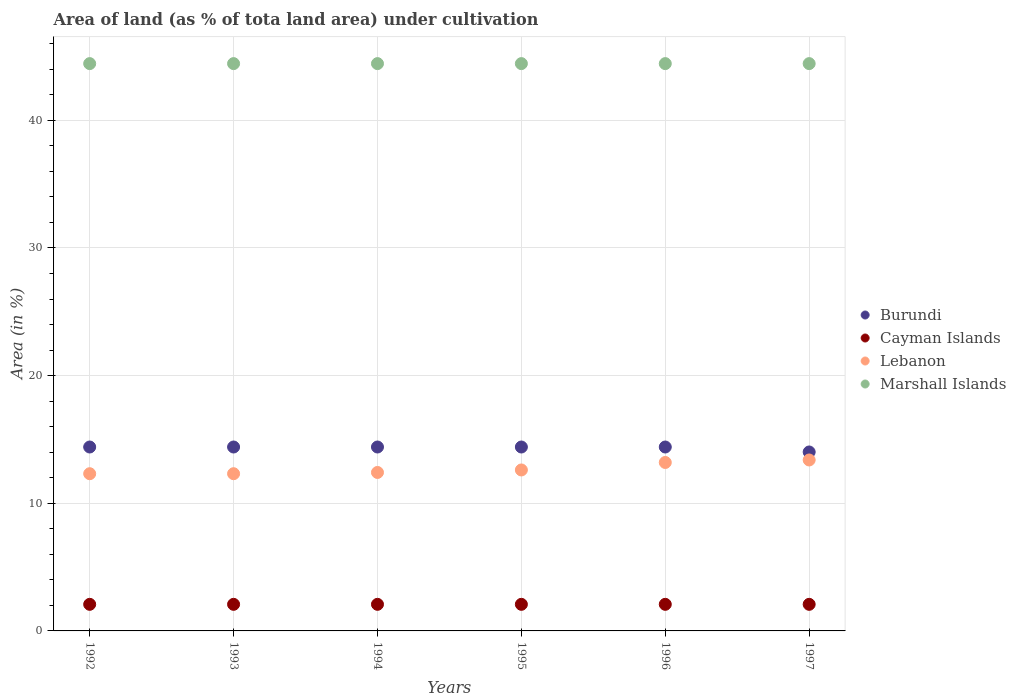Is the number of dotlines equal to the number of legend labels?
Offer a very short reply. Yes. What is the percentage of land under cultivation in Burundi in 1993?
Your answer should be compact. 14.41. Across all years, what is the maximum percentage of land under cultivation in Marshall Islands?
Provide a short and direct response. 44.44. Across all years, what is the minimum percentage of land under cultivation in Lebanon?
Provide a short and direct response. 12.32. In which year was the percentage of land under cultivation in Cayman Islands maximum?
Keep it short and to the point. 1992. In which year was the percentage of land under cultivation in Lebanon minimum?
Keep it short and to the point. 1992. What is the total percentage of land under cultivation in Burundi in the graph?
Provide a succinct answer. 86.06. What is the difference between the percentage of land under cultivation in Lebanon in 1992 and that in 1994?
Your answer should be compact. -0.1. What is the difference between the percentage of land under cultivation in Lebanon in 1993 and the percentage of land under cultivation in Cayman Islands in 1995?
Give a very brief answer. 10.23. What is the average percentage of land under cultivation in Lebanon per year?
Offer a very short reply. 12.71. In the year 1992, what is the difference between the percentage of land under cultivation in Burundi and percentage of land under cultivation in Lebanon?
Provide a short and direct response. 2.09. In how many years, is the percentage of land under cultivation in Lebanon greater than 16 %?
Offer a terse response. 0. What is the ratio of the percentage of land under cultivation in Lebanon in 1995 to that in 1996?
Provide a succinct answer. 0.96. Is the difference between the percentage of land under cultivation in Burundi in 1992 and 1993 greater than the difference between the percentage of land under cultivation in Lebanon in 1992 and 1993?
Your response must be concise. No. What is the difference between the highest and the lowest percentage of land under cultivation in Burundi?
Keep it short and to the point. 0.39. In how many years, is the percentage of land under cultivation in Burundi greater than the average percentage of land under cultivation in Burundi taken over all years?
Your response must be concise. 5. Is the sum of the percentage of land under cultivation in Lebanon in 1992 and 1993 greater than the maximum percentage of land under cultivation in Burundi across all years?
Make the answer very short. Yes. Is it the case that in every year, the sum of the percentage of land under cultivation in Burundi and percentage of land under cultivation in Lebanon  is greater than the sum of percentage of land under cultivation in Marshall Islands and percentage of land under cultivation in Cayman Islands?
Make the answer very short. Yes. Is it the case that in every year, the sum of the percentage of land under cultivation in Cayman Islands and percentage of land under cultivation in Marshall Islands  is greater than the percentage of land under cultivation in Burundi?
Your response must be concise. Yes. Is the percentage of land under cultivation in Lebanon strictly greater than the percentage of land under cultivation in Cayman Islands over the years?
Provide a succinct answer. Yes. Is the percentage of land under cultivation in Burundi strictly less than the percentage of land under cultivation in Marshall Islands over the years?
Your answer should be very brief. Yes. How many years are there in the graph?
Offer a very short reply. 6. What is the difference between two consecutive major ticks on the Y-axis?
Make the answer very short. 10. How many legend labels are there?
Offer a very short reply. 4. How are the legend labels stacked?
Offer a terse response. Vertical. What is the title of the graph?
Make the answer very short. Area of land (as % of tota land area) under cultivation. What is the label or title of the X-axis?
Make the answer very short. Years. What is the label or title of the Y-axis?
Make the answer very short. Area (in %). What is the Area (in %) of Burundi in 1992?
Ensure brevity in your answer.  14.41. What is the Area (in %) of Cayman Islands in 1992?
Your answer should be compact. 2.08. What is the Area (in %) of Lebanon in 1992?
Offer a terse response. 12.32. What is the Area (in %) in Marshall Islands in 1992?
Provide a succinct answer. 44.44. What is the Area (in %) in Burundi in 1993?
Your answer should be very brief. 14.41. What is the Area (in %) of Cayman Islands in 1993?
Your answer should be compact. 2.08. What is the Area (in %) of Lebanon in 1993?
Offer a very short reply. 12.32. What is the Area (in %) in Marshall Islands in 1993?
Keep it short and to the point. 44.44. What is the Area (in %) in Burundi in 1994?
Your response must be concise. 14.41. What is the Area (in %) of Cayman Islands in 1994?
Make the answer very short. 2.08. What is the Area (in %) in Lebanon in 1994?
Provide a succinct answer. 12.41. What is the Area (in %) of Marshall Islands in 1994?
Keep it short and to the point. 44.44. What is the Area (in %) of Burundi in 1995?
Ensure brevity in your answer.  14.41. What is the Area (in %) in Cayman Islands in 1995?
Ensure brevity in your answer.  2.08. What is the Area (in %) of Lebanon in 1995?
Ensure brevity in your answer.  12.61. What is the Area (in %) of Marshall Islands in 1995?
Provide a short and direct response. 44.44. What is the Area (in %) in Burundi in 1996?
Your answer should be compact. 14.41. What is the Area (in %) of Cayman Islands in 1996?
Your answer should be very brief. 2.08. What is the Area (in %) in Lebanon in 1996?
Provide a short and direct response. 13.2. What is the Area (in %) in Marshall Islands in 1996?
Give a very brief answer. 44.44. What is the Area (in %) of Burundi in 1997?
Offer a terse response. 14.02. What is the Area (in %) in Cayman Islands in 1997?
Provide a short and direct response. 2.08. What is the Area (in %) of Lebanon in 1997?
Offer a very short reply. 13.39. What is the Area (in %) of Marshall Islands in 1997?
Give a very brief answer. 44.44. Across all years, what is the maximum Area (in %) of Burundi?
Your response must be concise. 14.41. Across all years, what is the maximum Area (in %) of Cayman Islands?
Your answer should be compact. 2.08. Across all years, what is the maximum Area (in %) in Lebanon?
Offer a terse response. 13.39. Across all years, what is the maximum Area (in %) of Marshall Islands?
Provide a short and direct response. 44.44. Across all years, what is the minimum Area (in %) of Burundi?
Provide a short and direct response. 14.02. Across all years, what is the minimum Area (in %) in Cayman Islands?
Ensure brevity in your answer.  2.08. Across all years, what is the minimum Area (in %) in Lebanon?
Your response must be concise. 12.32. Across all years, what is the minimum Area (in %) of Marshall Islands?
Offer a terse response. 44.44. What is the total Area (in %) of Burundi in the graph?
Ensure brevity in your answer.  86.06. What is the total Area (in %) in Cayman Islands in the graph?
Offer a terse response. 12.5. What is the total Area (in %) in Lebanon in the graph?
Make the answer very short. 76.25. What is the total Area (in %) of Marshall Islands in the graph?
Provide a short and direct response. 266.67. What is the difference between the Area (in %) in Burundi in 1992 and that in 1993?
Offer a terse response. 0. What is the difference between the Area (in %) in Lebanon in 1992 and that in 1993?
Provide a succinct answer. 0. What is the difference between the Area (in %) of Burundi in 1992 and that in 1994?
Keep it short and to the point. 0. What is the difference between the Area (in %) of Lebanon in 1992 and that in 1994?
Provide a succinct answer. -0.1. What is the difference between the Area (in %) in Burundi in 1992 and that in 1995?
Keep it short and to the point. 0. What is the difference between the Area (in %) in Lebanon in 1992 and that in 1995?
Ensure brevity in your answer.  -0.29. What is the difference between the Area (in %) in Marshall Islands in 1992 and that in 1995?
Keep it short and to the point. 0. What is the difference between the Area (in %) in Lebanon in 1992 and that in 1996?
Ensure brevity in your answer.  -0.88. What is the difference between the Area (in %) of Marshall Islands in 1992 and that in 1996?
Give a very brief answer. 0. What is the difference between the Area (in %) of Burundi in 1992 and that in 1997?
Keep it short and to the point. 0.39. What is the difference between the Area (in %) in Lebanon in 1992 and that in 1997?
Your answer should be very brief. -1.08. What is the difference between the Area (in %) of Marshall Islands in 1992 and that in 1997?
Keep it short and to the point. 0. What is the difference between the Area (in %) in Cayman Islands in 1993 and that in 1994?
Provide a succinct answer. 0. What is the difference between the Area (in %) in Lebanon in 1993 and that in 1994?
Give a very brief answer. -0.1. What is the difference between the Area (in %) in Marshall Islands in 1993 and that in 1994?
Ensure brevity in your answer.  0. What is the difference between the Area (in %) in Burundi in 1993 and that in 1995?
Keep it short and to the point. 0. What is the difference between the Area (in %) in Lebanon in 1993 and that in 1995?
Your answer should be very brief. -0.29. What is the difference between the Area (in %) of Cayman Islands in 1993 and that in 1996?
Your response must be concise. 0. What is the difference between the Area (in %) in Lebanon in 1993 and that in 1996?
Keep it short and to the point. -0.88. What is the difference between the Area (in %) in Burundi in 1993 and that in 1997?
Offer a terse response. 0.39. What is the difference between the Area (in %) in Lebanon in 1993 and that in 1997?
Your response must be concise. -1.08. What is the difference between the Area (in %) in Marshall Islands in 1993 and that in 1997?
Ensure brevity in your answer.  0. What is the difference between the Area (in %) of Lebanon in 1994 and that in 1995?
Offer a terse response. -0.2. What is the difference between the Area (in %) in Marshall Islands in 1994 and that in 1995?
Offer a terse response. 0. What is the difference between the Area (in %) of Cayman Islands in 1994 and that in 1996?
Offer a very short reply. 0. What is the difference between the Area (in %) of Lebanon in 1994 and that in 1996?
Ensure brevity in your answer.  -0.78. What is the difference between the Area (in %) of Burundi in 1994 and that in 1997?
Your answer should be compact. 0.39. What is the difference between the Area (in %) of Lebanon in 1994 and that in 1997?
Provide a short and direct response. -0.98. What is the difference between the Area (in %) of Burundi in 1995 and that in 1996?
Offer a terse response. 0. What is the difference between the Area (in %) of Lebanon in 1995 and that in 1996?
Keep it short and to the point. -0.59. What is the difference between the Area (in %) in Marshall Islands in 1995 and that in 1996?
Make the answer very short. 0. What is the difference between the Area (in %) in Burundi in 1995 and that in 1997?
Provide a short and direct response. 0.39. What is the difference between the Area (in %) of Cayman Islands in 1995 and that in 1997?
Provide a succinct answer. 0. What is the difference between the Area (in %) in Lebanon in 1995 and that in 1997?
Your answer should be very brief. -0.78. What is the difference between the Area (in %) in Burundi in 1996 and that in 1997?
Your response must be concise. 0.39. What is the difference between the Area (in %) in Lebanon in 1996 and that in 1997?
Your answer should be very brief. -0.2. What is the difference between the Area (in %) of Burundi in 1992 and the Area (in %) of Cayman Islands in 1993?
Offer a very short reply. 12.32. What is the difference between the Area (in %) in Burundi in 1992 and the Area (in %) in Lebanon in 1993?
Keep it short and to the point. 2.09. What is the difference between the Area (in %) in Burundi in 1992 and the Area (in %) in Marshall Islands in 1993?
Your response must be concise. -30.04. What is the difference between the Area (in %) of Cayman Islands in 1992 and the Area (in %) of Lebanon in 1993?
Your answer should be compact. -10.23. What is the difference between the Area (in %) in Cayman Islands in 1992 and the Area (in %) in Marshall Islands in 1993?
Your answer should be very brief. -42.36. What is the difference between the Area (in %) in Lebanon in 1992 and the Area (in %) in Marshall Islands in 1993?
Ensure brevity in your answer.  -32.13. What is the difference between the Area (in %) of Burundi in 1992 and the Area (in %) of Cayman Islands in 1994?
Offer a terse response. 12.32. What is the difference between the Area (in %) in Burundi in 1992 and the Area (in %) in Lebanon in 1994?
Your response must be concise. 1.99. What is the difference between the Area (in %) of Burundi in 1992 and the Area (in %) of Marshall Islands in 1994?
Provide a succinct answer. -30.04. What is the difference between the Area (in %) in Cayman Islands in 1992 and the Area (in %) in Lebanon in 1994?
Ensure brevity in your answer.  -10.33. What is the difference between the Area (in %) in Cayman Islands in 1992 and the Area (in %) in Marshall Islands in 1994?
Ensure brevity in your answer.  -42.36. What is the difference between the Area (in %) of Lebanon in 1992 and the Area (in %) of Marshall Islands in 1994?
Provide a succinct answer. -32.13. What is the difference between the Area (in %) in Burundi in 1992 and the Area (in %) in Cayman Islands in 1995?
Offer a very short reply. 12.32. What is the difference between the Area (in %) in Burundi in 1992 and the Area (in %) in Lebanon in 1995?
Your answer should be compact. 1.8. What is the difference between the Area (in %) of Burundi in 1992 and the Area (in %) of Marshall Islands in 1995?
Your response must be concise. -30.04. What is the difference between the Area (in %) in Cayman Islands in 1992 and the Area (in %) in Lebanon in 1995?
Offer a terse response. -10.53. What is the difference between the Area (in %) of Cayman Islands in 1992 and the Area (in %) of Marshall Islands in 1995?
Offer a very short reply. -42.36. What is the difference between the Area (in %) in Lebanon in 1992 and the Area (in %) in Marshall Islands in 1995?
Keep it short and to the point. -32.13. What is the difference between the Area (in %) in Burundi in 1992 and the Area (in %) in Cayman Islands in 1996?
Your response must be concise. 12.32. What is the difference between the Area (in %) of Burundi in 1992 and the Area (in %) of Lebanon in 1996?
Provide a succinct answer. 1.21. What is the difference between the Area (in %) of Burundi in 1992 and the Area (in %) of Marshall Islands in 1996?
Ensure brevity in your answer.  -30.04. What is the difference between the Area (in %) of Cayman Islands in 1992 and the Area (in %) of Lebanon in 1996?
Offer a very short reply. -11.11. What is the difference between the Area (in %) of Cayman Islands in 1992 and the Area (in %) of Marshall Islands in 1996?
Ensure brevity in your answer.  -42.36. What is the difference between the Area (in %) in Lebanon in 1992 and the Area (in %) in Marshall Islands in 1996?
Provide a succinct answer. -32.13. What is the difference between the Area (in %) of Burundi in 1992 and the Area (in %) of Cayman Islands in 1997?
Keep it short and to the point. 12.32. What is the difference between the Area (in %) of Burundi in 1992 and the Area (in %) of Lebanon in 1997?
Keep it short and to the point. 1.02. What is the difference between the Area (in %) of Burundi in 1992 and the Area (in %) of Marshall Islands in 1997?
Offer a terse response. -30.04. What is the difference between the Area (in %) in Cayman Islands in 1992 and the Area (in %) in Lebanon in 1997?
Ensure brevity in your answer.  -11.31. What is the difference between the Area (in %) of Cayman Islands in 1992 and the Area (in %) of Marshall Islands in 1997?
Offer a terse response. -42.36. What is the difference between the Area (in %) in Lebanon in 1992 and the Area (in %) in Marshall Islands in 1997?
Provide a succinct answer. -32.13. What is the difference between the Area (in %) of Burundi in 1993 and the Area (in %) of Cayman Islands in 1994?
Provide a succinct answer. 12.32. What is the difference between the Area (in %) of Burundi in 1993 and the Area (in %) of Lebanon in 1994?
Offer a terse response. 1.99. What is the difference between the Area (in %) of Burundi in 1993 and the Area (in %) of Marshall Islands in 1994?
Offer a very short reply. -30.04. What is the difference between the Area (in %) in Cayman Islands in 1993 and the Area (in %) in Lebanon in 1994?
Your response must be concise. -10.33. What is the difference between the Area (in %) in Cayman Islands in 1993 and the Area (in %) in Marshall Islands in 1994?
Offer a terse response. -42.36. What is the difference between the Area (in %) in Lebanon in 1993 and the Area (in %) in Marshall Islands in 1994?
Your answer should be compact. -32.13. What is the difference between the Area (in %) in Burundi in 1993 and the Area (in %) in Cayman Islands in 1995?
Your answer should be very brief. 12.32. What is the difference between the Area (in %) of Burundi in 1993 and the Area (in %) of Lebanon in 1995?
Offer a very short reply. 1.8. What is the difference between the Area (in %) of Burundi in 1993 and the Area (in %) of Marshall Islands in 1995?
Ensure brevity in your answer.  -30.04. What is the difference between the Area (in %) in Cayman Islands in 1993 and the Area (in %) in Lebanon in 1995?
Make the answer very short. -10.53. What is the difference between the Area (in %) in Cayman Islands in 1993 and the Area (in %) in Marshall Islands in 1995?
Provide a short and direct response. -42.36. What is the difference between the Area (in %) of Lebanon in 1993 and the Area (in %) of Marshall Islands in 1995?
Offer a very short reply. -32.13. What is the difference between the Area (in %) in Burundi in 1993 and the Area (in %) in Cayman Islands in 1996?
Provide a succinct answer. 12.32. What is the difference between the Area (in %) in Burundi in 1993 and the Area (in %) in Lebanon in 1996?
Ensure brevity in your answer.  1.21. What is the difference between the Area (in %) of Burundi in 1993 and the Area (in %) of Marshall Islands in 1996?
Provide a succinct answer. -30.04. What is the difference between the Area (in %) in Cayman Islands in 1993 and the Area (in %) in Lebanon in 1996?
Your response must be concise. -11.11. What is the difference between the Area (in %) of Cayman Islands in 1993 and the Area (in %) of Marshall Islands in 1996?
Provide a succinct answer. -42.36. What is the difference between the Area (in %) in Lebanon in 1993 and the Area (in %) in Marshall Islands in 1996?
Provide a short and direct response. -32.13. What is the difference between the Area (in %) of Burundi in 1993 and the Area (in %) of Cayman Islands in 1997?
Your answer should be compact. 12.32. What is the difference between the Area (in %) of Burundi in 1993 and the Area (in %) of Lebanon in 1997?
Your answer should be compact. 1.02. What is the difference between the Area (in %) of Burundi in 1993 and the Area (in %) of Marshall Islands in 1997?
Make the answer very short. -30.04. What is the difference between the Area (in %) in Cayman Islands in 1993 and the Area (in %) in Lebanon in 1997?
Your response must be concise. -11.31. What is the difference between the Area (in %) in Cayman Islands in 1993 and the Area (in %) in Marshall Islands in 1997?
Offer a very short reply. -42.36. What is the difference between the Area (in %) of Lebanon in 1993 and the Area (in %) of Marshall Islands in 1997?
Give a very brief answer. -32.13. What is the difference between the Area (in %) in Burundi in 1994 and the Area (in %) in Cayman Islands in 1995?
Ensure brevity in your answer.  12.32. What is the difference between the Area (in %) of Burundi in 1994 and the Area (in %) of Lebanon in 1995?
Provide a succinct answer. 1.8. What is the difference between the Area (in %) of Burundi in 1994 and the Area (in %) of Marshall Islands in 1995?
Your response must be concise. -30.04. What is the difference between the Area (in %) of Cayman Islands in 1994 and the Area (in %) of Lebanon in 1995?
Ensure brevity in your answer.  -10.53. What is the difference between the Area (in %) in Cayman Islands in 1994 and the Area (in %) in Marshall Islands in 1995?
Offer a very short reply. -42.36. What is the difference between the Area (in %) in Lebanon in 1994 and the Area (in %) in Marshall Islands in 1995?
Your answer should be very brief. -32.03. What is the difference between the Area (in %) of Burundi in 1994 and the Area (in %) of Cayman Islands in 1996?
Provide a succinct answer. 12.32. What is the difference between the Area (in %) in Burundi in 1994 and the Area (in %) in Lebanon in 1996?
Your response must be concise. 1.21. What is the difference between the Area (in %) in Burundi in 1994 and the Area (in %) in Marshall Islands in 1996?
Give a very brief answer. -30.04. What is the difference between the Area (in %) of Cayman Islands in 1994 and the Area (in %) of Lebanon in 1996?
Offer a terse response. -11.11. What is the difference between the Area (in %) of Cayman Islands in 1994 and the Area (in %) of Marshall Islands in 1996?
Offer a very short reply. -42.36. What is the difference between the Area (in %) of Lebanon in 1994 and the Area (in %) of Marshall Islands in 1996?
Your answer should be compact. -32.03. What is the difference between the Area (in %) in Burundi in 1994 and the Area (in %) in Cayman Islands in 1997?
Make the answer very short. 12.32. What is the difference between the Area (in %) of Burundi in 1994 and the Area (in %) of Lebanon in 1997?
Provide a succinct answer. 1.02. What is the difference between the Area (in %) of Burundi in 1994 and the Area (in %) of Marshall Islands in 1997?
Your response must be concise. -30.04. What is the difference between the Area (in %) of Cayman Islands in 1994 and the Area (in %) of Lebanon in 1997?
Your answer should be compact. -11.31. What is the difference between the Area (in %) in Cayman Islands in 1994 and the Area (in %) in Marshall Islands in 1997?
Your answer should be compact. -42.36. What is the difference between the Area (in %) of Lebanon in 1994 and the Area (in %) of Marshall Islands in 1997?
Make the answer very short. -32.03. What is the difference between the Area (in %) of Burundi in 1995 and the Area (in %) of Cayman Islands in 1996?
Give a very brief answer. 12.32. What is the difference between the Area (in %) in Burundi in 1995 and the Area (in %) in Lebanon in 1996?
Ensure brevity in your answer.  1.21. What is the difference between the Area (in %) in Burundi in 1995 and the Area (in %) in Marshall Islands in 1996?
Keep it short and to the point. -30.04. What is the difference between the Area (in %) of Cayman Islands in 1995 and the Area (in %) of Lebanon in 1996?
Your answer should be very brief. -11.11. What is the difference between the Area (in %) of Cayman Islands in 1995 and the Area (in %) of Marshall Islands in 1996?
Offer a very short reply. -42.36. What is the difference between the Area (in %) in Lebanon in 1995 and the Area (in %) in Marshall Islands in 1996?
Provide a succinct answer. -31.83. What is the difference between the Area (in %) in Burundi in 1995 and the Area (in %) in Cayman Islands in 1997?
Make the answer very short. 12.32. What is the difference between the Area (in %) in Burundi in 1995 and the Area (in %) in Lebanon in 1997?
Your answer should be compact. 1.02. What is the difference between the Area (in %) of Burundi in 1995 and the Area (in %) of Marshall Islands in 1997?
Give a very brief answer. -30.04. What is the difference between the Area (in %) of Cayman Islands in 1995 and the Area (in %) of Lebanon in 1997?
Your answer should be compact. -11.31. What is the difference between the Area (in %) in Cayman Islands in 1995 and the Area (in %) in Marshall Islands in 1997?
Your answer should be very brief. -42.36. What is the difference between the Area (in %) of Lebanon in 1995 and the Area (in %) of Marshall Islands in 1997?
Provide a short and direct response. -31.83. What is the difference between the Area (in %) of Burundi in 1996 and the Area (in %) of Cayman Islands in 1997?
Offer a very short reply. 12.32. What is the difference between the Area (in %) in Burundi in 1996 and the Area (in %) in Lebanon in 1997?
Your answer should be very brief. 1.02. What is the difference between the Area (in %) of Burundi in 1996 and the Area (in %) of Marshall Islands in 1997?
Your response must be concise. -30.04. What is the difference between the Area (in %) in Cayman Islands in 1996 and the Area (in %) in Lebanon in 1997?
Keep it short and to the point. -11.31. What is the difference between the Area (in %) of Cayman Islands in 1996 and the Area (in %) of Marshall Islands in 1997?
Give a very brief answer. -42.36. What is the difference between the Area (in %) in Lebanon in 1996 and the Area (in %) in Marshall Islands in 1997?
Offer a terse response. -31.25. What is the average Area (in %) in Burundi per year?
Provide a succinct answer. 14.34. What is the average Area (in %) in Cayman Islands per year?
Keep it short and to the point. 2.08. What is the average Area (in %) of Lebanon per year?
Provide a short and direct response. 12.71. What is the average Area (in %) in Marshall Islands per year?
Provide a short and direct response. 44.44. In the year 1992, what is the difference between the Area (in %) in Burundi and Area (in %) in Cayman Islands?
Your response must be concise. 12.32. In the year 1992, what is the difference between the Area (in %) in Burundi and Area (in %) in Lebanon?
Offer a very short reply. 2.09. In the year 1992, what is the difference between the Area (in %) of Burundi and Area (in %) of Marshall Islands?
Your response must be concise. -30.04. In the year 1992, what is the difference between the Area (in %) in Cayman Islands and Area (in %) in Lebanon?
Provide a short and direct response. -10.23. In the year 1992, what is the difference between the Area (in %) of Cayman Islands and Area (in %) of Marshall Islands?
Provide a succinct answer. -42.36. In the year 1992, what is the difference between the Area (in %) of Lebanon and Area (in %) of Marshall Islands?
Your response must be concise. -32.13. In the year 1993, what is the difference between the Area (in %) in Burundi and Area (in %) in Cayman Islands?
Offer a terse response. 12.32. In the year 1993, what is the difference between the Area (in %) in Burundi and Area (in %) in Lebanon?
Make the answer very short. 2.09. In the year 1993, what is the difference between the Area (in %) of Burundi and Area (in %) of Marshall Islands?
Provide a short and direct response. -30.04. In the year 1993, what is the difference between the Area (in %) in Cayman Islands and Area (in %) in Lebanon?
Your answer should be compact. -10.23. In the year 1993, what is the difference between the Area (in %) of Cayman Islands and Area (in %) of Marshall Islands?
Your response must be concise. -42.36. In the year 1993, what is the difference between the Area (in %) in Lebanon and Area (in %) in Marshall Islands?
Offer a very short reply. -32.13. In the year 1994, what is the difference between the Area (in %) in Burundi and Area (in %) in Cayman Islands?
Your response must be concise. 12.32. In the year 1994, what is the difference between the Area (in %) of Burundi and Area (in %) of Lebanon?
Provide a succinct answer. 1.99. In the year 1994, what is the difference between the Area (in %) in Burundi and Area (in %) in Marshall Islands?
Ensure brevity in your answer.  -30.04. In the year 1994, what is the difference between the Area (in %) of Cayman Islands and Area (in %) of Lebanon?
Offer a very short reply. -10.33. In the year 1994, what is the difference between the Area (in %) of Cayman Islands and Area (in %) of Marshall Islands?
Offer a very short reply. -42.36. In the year 1994, what is the difference between the Area (in %) in Lebanon and Area (in %) in Marshall Islands?
Provide a succinct answer. -32.03. In the year 1995, what is the difference between the Area (in %) in Burundi and Area (in %) in Cayman Islands?
Your answer should be very brief. 12.32. In the year 1995, what is the difference between the Area (in %) of Burundi and Area (in %) of Lebanon?
Give a very brief answer. 1.8. In the year 1995, what is the difference between the Area (in %) in Burundi and Area (in %) in Marshall Islands?
Give a very brief answer. -30.04. In the year 1995, what is the difference between the Area (in %) of Cayman Islands and Area (in %) of Lebanon?
Ensure brevity in your answer.  -10.53. In the year 1995, what is the difference between the Area (in %) in Cayman Islands and Area (in %) in Marshall Islands?
Provide a short and direct response. -42.36. In the year 1995, what is the difference between the Area (in %) in Lebanon and Area (in %) in Marshall Islands?
Provide a succinct answer. -31.83. In the year 1996, what is the difference between the Area (in %) of Burundi and Area (in %) of Cayman Islands?
Your answer should be compact. 12.32. In the year 1996, what is the difference between the Area (in %) of Burundi and Area (in %) of Lebanon?
Offer a terse response. 1.21. In the year 1996, what is the difference between the Area (in %) in Burundi and Area (in %) in Marshall Islands?
Give a very brief answer. -30.04. In the year 1996, what is the difference between the Area (in %) in Cayman Islands and Area (in %) in Lebanon?
Offer a very short reply. -11.11. In the year 1996, what is the difference between the Area (in %) in Cayman Islands and Area (in %) in Marshall Islands?
Your response must be concise. -42.36. In the year 1996, what is the difference between the Area (in %) in Lebanon and Area (in %) in Marshall Islands?
Keep it short and to the point. -31.25. In the year 1997, what is the difference between the Area (in %) in Burundi and Area (in %) in Cayman Islands?
Your answer should be very brief. 11.94. In the year 1997, what is the difference between the Area (in %) of Burundi and Area (in %) of Lebanon?
Ensure brevity in your answer.  0.63. In the year 1997, what is the difference between the Area (in %) in Burundi and Area (in %) in Marshall Islands?
Provide a short and direct response. -30.43. In the year 1997, what is the difference between the Area (in %) in Cayman Islands and Area (in %) in Lebanon?
Ensure brevity in your answer.  -11.31. In the year 1997, what is the difference between the Area (in %) of Cayman Islands and Area (in %) of Marshall Islands?
Provide a short and direct response. -42.36. In the year 1997, what is the difference between the Area (in %) of Lebanon and Area (in %) of Marshall Islands?
Provide a succinct answer. -31.05. What is the ratio of the Area (in %) of Burundi in 1992 to that in 1993?
Ensure brevity in your answer.  1. What is the ratio of the Area (in %) in Cayman Islands in 1992 to that in 1993?
Give a very brief answer. 1. What is the ratio of the Area (in %) of Marshall Islands in 1992 to that in 1993?
Your answer should be very brief. 1. What is the ratio of the Area (in %) of Cayman Islands in 1992 to that in 1994?
Make the answer very short. 1. What is the ratio of the Area (in %) in Lebanon in 1992 to that in 1994?
Offer a very short reply. 0.99. What is the ratio of the Area (in %) in Burundi in 1992 to that in 1995?
Provide a succinct answer. 1. What is the ratio of the Area (in %) of Cayman Islands in 1992 to that in 1995?
Your answer should be compact. 1. What is the ratio of the Area (in %) in Lebanon in 1992 to that in 1995?
Provide a succinct answer. 0.98. What is the ratio of the Area (in %) of Burundi in 1992 to that in 1997?
Offer a very short reply. 1.03. What is the ratio of the Area (in %) in Lebanon in 1992 to that in 1997?
Provide a succinct answer. 0.92. What is the ratio of the Area (in %) in Marshall Islands in 1992 to that in 1997?
Give a very brief answer. 1. What is the ratio of the Area (in %) in Marshall Islands in 1993 to that in 1994?
Offer a terse response. 1. What is the ratio of the Area (in %) in Burundi in 1993 to that in 1995?
Provide a short and direct response. 1. What is the ratio of the Area (in %) in Cayman Islands in 1993 to that in 1995?
Offer a very short reply. 1. What is the ratio of the Area (in %) of Lebanon in 1993 to that in 1995?
Your response must be concise. 0.98. What is the ratio of the Area (in %) of Burundi in 1993 to that in 1996?
Your answer should be compact. 1. What is the ratio of the Area (in %) of Cayman Islands in 1993 to that in 1996?
Your response must be concise. 1. What is the ratio of the Area (in %) of Lebanon in 1993 to that in 1996?
Make the answer very short. 0.93. What is the ratio of the Area (in %) in Marshall Islands in 1993 to that in 1996?
Make the answer very short. 1. What is the ratio of the Area (in %) in Burundi in 1993 to that in 1997?
Offer a terse response. 1.03. What is the ratio of the Area (in %) of Cayman Islands in 1993 to that in 1997?
Offer a terse response. 1. What is the ratio of the Area (in %) in Lebanon in 1993 to that in 1997?
Make the answer very short. 0.92. What is the ratio of the Area (in %) in Cayman Islands in 1994 to that in 1995?
Provide a short and direct response. 1. What is the ratio of the Area (in %) in Lebanon in 1994 to that in 1995?
Make the answer very short. 0.98. What is the ratio of the Area (in %) in Marshall Islands in 1994 to that in 1995?
Offer a very short reply. 1. What is the ratio of the Area (in %) of Lebanon in 1994 to that in 1996?
Offer a very short reply. 0.94. What is the ratio of the Area (in %) in Marshall Islands in 1994 to that in 1996?
Your answer should be compact. 1. What is the ratio of the Area (in %) in Burundi in 1994 to that in 1997?
Provide a succinct answer. 1.03. What is the ratio of the Area (in %) in Cayman Islands in 1994 to that in 1997?
Make the answer very short. 1. What is the ratio of the Area (in %) of Lebanon in 1994 to that in 1997?
Offer a very short reply. 0.93. What is the ratio of the Area (in %) in Marshall Islands in 1994 to that in 1997?
Offer a terse response. 1. What is the ratio of the Area (in %) of Burundi in 1995 to that in 1996?
Give a very brief answer. 1. What is the ratio of the Area (in %) of Cayman Islands in 1995 to that in 1996?
Your response must be concise. 1. What is the ratio of the Area (in %) of Lebanon in 1995 to that in 1996?
Give a very brief answer. 0.96. What is the ratio of the Area (in %) of Burundi in 1995 to that in 1997?
Ensure brevity in your answer.  1.03. What is the ratio of the Area (in %) in Cayman Islands in 1995 to that in 1997?
Give a very brief answer. 1. What is the ratio of the Area (in %) in Lebanon in 1995 to that in 1997?
Your response must be concise. 0.94. What is the ratio of the Area (in %) in Burundi in 1996 to that in 1997?
Offer a terse response. 1.03. What is the ratio of the Area (in %) in Lebanon in 1996 to that in 1997?
Your answer should be compact. 0.99. What is the ratio of the Area (in %) of Marshall Islands in 1996 to that in 1997?
Keep it short and to the point. 1. What is the difference between the highest and the second highest Area (in %) in Burundi?
Make the answer very short. 0. What is the difference between the highest and the second highest Area (in %) of Cayman Islands?
Provide a succinct answer. 0. What is the difference between the highest and the second highest Area (in %) in Lebanon?
Your response must be concise. 0.2. What is the difference between the highest and the second highest Area (in %) in Marshall Islands?
Give a very brief answer. 0. What is the difference between the highest and the lowest Area (in %) of Burundi?
Offer a terse response. 0.39. What is the difference between the highest and the lowest Area (in %) in Lebanon?
Offer a terse response. 1.08. What is the difference between the highest and the lowest Area (in %) of Marshall Islands?
Your answer should be very brief. 0. 